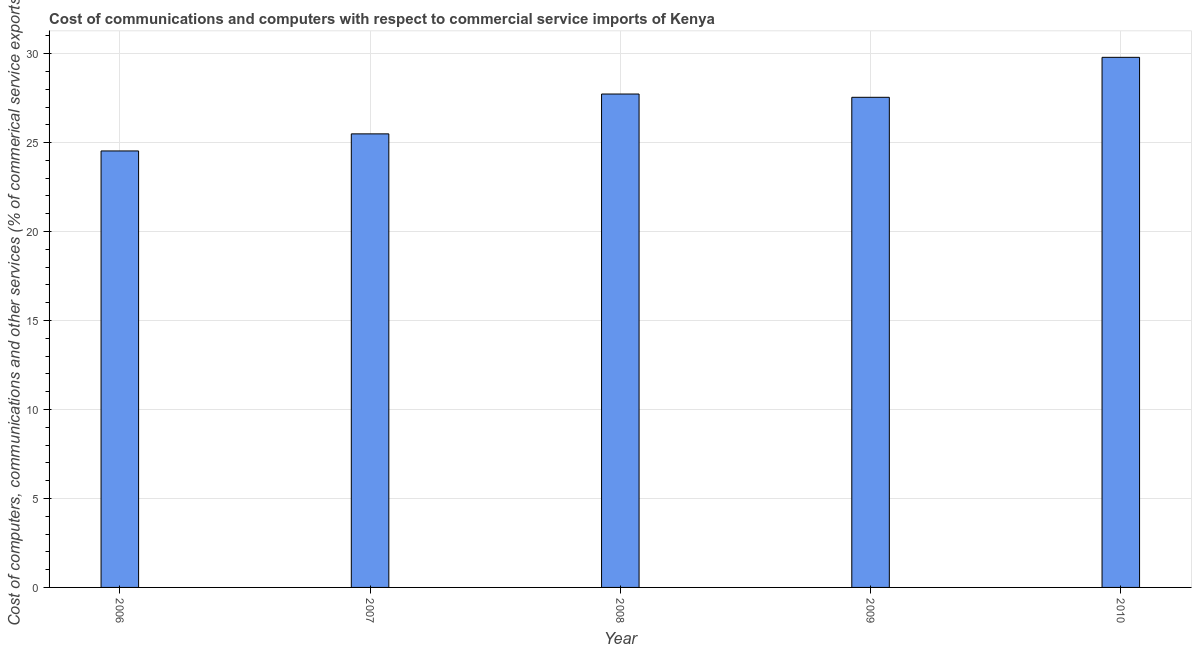Does the graph contain any zero values?
Your answer should be compact. No. What is the title of the graph?
Your answer should be very brief. Cost of communications and computers with respect to commercial service imports of Kenya. What is the label or title of the Y-axis?
Offer a terse response. Cost of computers, communications and other services (% of commerical service exports). What is the  computer and other services in 2007?
Keep it short and to the point. 25.49. Across all years, what is the maximum cost of communications?
Give a very brief answer. 29.79. Across all years, what is the minimum cost of communications?
Keep it short and to the point. 24.53. What is the sum of the cost of communications?
Provide a short and direct response. 135.09. What is the difference between the cost of communications in 2006 and 2008?
Your response must be concise. -3.2. What is the average  computer and other services per year?
Your answer should be very brief. 27.02. What is the median cost of communications?
Your answer should be compact. 27.55. In how many years, is the  computer and other services greater than 16 %?
Make the answer very short. 5. Do a majority of the years between 2008 and 2009 (inclusive) have  computer and other services greater than 24 %?
Ensure brevity in your answer.  Yes. What is the ratio of the cost of communications in 2009 to that in 2010?
Provide a short and direct response. 0.93. What is the difference between the highest and the second highest  computer and other services?
Provide a short and direct response. 2.06. Is the sum of the  computer and other services in 2009 and 2010 greater than the maximum  computer and other services across all years?
Offer a terse response. Yes. What is the difference between the highest and the lowest  computer and other services?
Keep it short and to the point. 5.26. In how many years, is the cost of communications greater than the average cost of communications taken over all years?
Your answer should be compact. 3. How many bars are there?
Offer a very short reply. 5. Are all the bars in the graph horizontal?
Offer a very short reply. No. What is the difference between two consecutive major ticks on the Y-axis?
Offer a terse response. 5. What is the Cost of computers, communications and other services (% of commerical service exports) in 2006?
Offer a very short reply. 24.53. What is the Cost of computers, communications and other services (% of commerical service exports) of 2007?
Provide a succinct answer. 25.49. What is the Cost of computers, communications and other services (% of commerical service exports) of 2008?
Offer a terse response. 27.73. What is the Cost of computers, communications and other services (% of commerical service exports) in 2009?
Keep it short and to the point. 27.55. What is the Cost of computers, communications and other services (% of commerical service exports) of 2010?
Make the answer very short. 29.79. What is the difference between the Cost of computers, communications and other services (% of commerical service exports) in 2006 and 2007?
Give a very brief answer. -0.96. What is the difference between the Cost of computers, communications and other services (% of commerical service exports) in 2006 and 2008?
Your answer should be compact. -3.2. What is the difference between the Cost of computers, communications and other services (% of commerical service exports) in 2006 and 2009?
Offer a terse response. -3.02. What is the difference between the Cost of computers, communications and other services (% of commerical service exports) in 2006 and 2010?
Keep it short and to the point. -5.26. What is the difference between the Cost of computers, communications and other services (% of commerical service exports) in 2007 and 2008?
Your answer should be compact. -2.24. What is the difference between the Cost of computers, communications and other services (% of commerical service exports) in 2007 and 2009?
Make the answer very short. -2.06. What is the difference between the Cost of computers, communications and other services (% of commerical service exports) in 2007 and 2010?
Keep it short and to the point. -4.3. What is the difference between the Cost of computers, communications and other services (% of commerical service exports) in 2008 and 2009?
Provide a succinct answer. 0.18. What is the difference between the Cost of computers, communications and other services (% of commerical service exports) in 2008 and 2010?
Ensure brevity in your answer.  -2.06. What is the difference between the Cost of computers, communications and other services (% of commerical service exports) in 2009 and 2010?
Ensure brevity in your answer.  -2.25. What is the ratio of the Cost of computers, communications and other services (% of commerical service exports) in 2006 to that in 2007?
Your answer should be compact. 0.96. What is the ratio of the Cost of computers, communications and other services (% of commerical service exports) in 2006 to that in 2008?
Your answer should be very brief. 0.89. What is the ratio of the Cost of computers, communications and other services (% of commerical service exports) in 2006 to that in 2009?
Ensure brevity in your answer.  0.89. What is the ratio of the Cost of computers, communications and other services (% of commerical service exports) in 2006 to that in 2010?
Make the answer very short. 0.82. What is the ratio of the Cost of computers, communications and other services (% of commerical service exports) in 2007 to that in 2008?
Your response must be concise. 0.92. What is the ratio of the Cost of computers, communications and other services (% of commerical service exports) in 2007 to that in 2009?
Your response must be concise. 0.93. What is the ratio of the Cost of computers, communications and other services (% of commerical service exports) in 2007 to that in 2010?
Make the answer very short. 0.86. What is the ratio of the Cost of computers, communications and other services (% of commerical service exports) in 2008 to that in 2009?
Ensure brevity in your answer.  1.01. What is the ratio of the Cost of computers, communications and other services (% of commerical service exports) in 2009 to that in 2010?
Provide a succinct answer. 0.93. 